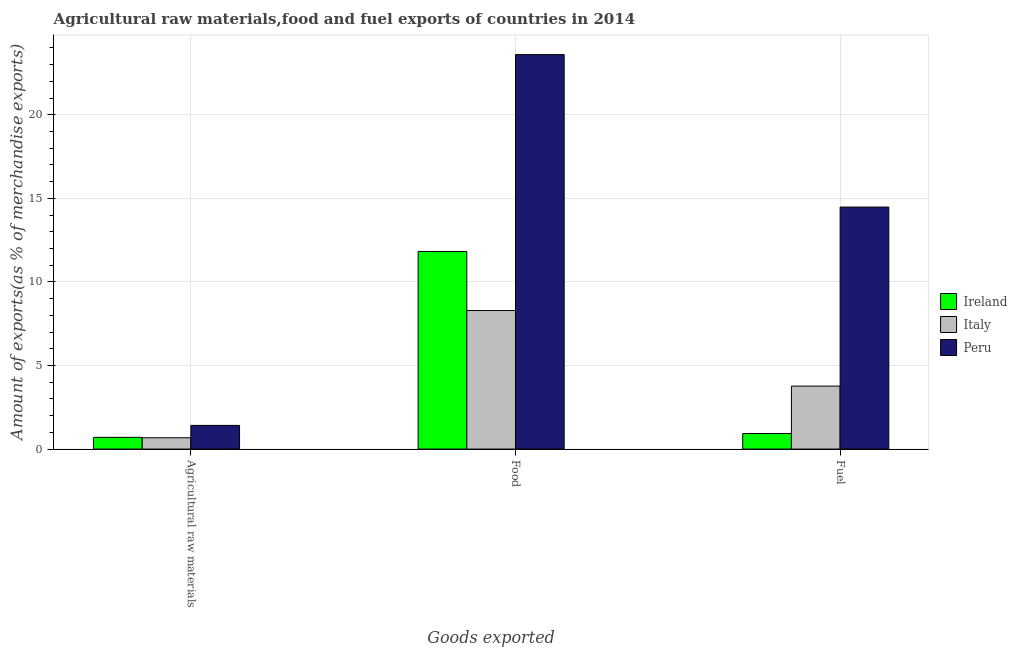Are the number of bars per tick equal to the number of legend labels?
Ensure brevity in your answer.  Yes. How many bars are there on the 3rd tick from the right?
Offer a terse response. 3. What is the label of the 2nd group of bars from the left?
Your answer should be compact. Food. What is the percentage of fuel exports in Ireland?
Your answer should be compact. 0.93. Across all countries, what is the maximum percentage of fuel exports?
Ensure brevity in your answer.  14.48. Across all countries, what is the minimum percentage of food exports?
Provide a succinct answer. 8.29. What is the total percentage of fuel exports in the graph?
Keep it short and to the point. 19.17. What is the difference between the percentage of food exports in Ireland and that in Italy?
Provide a short and direct response. 3.53. What is the difference between the percentage of food exports in Peru and the percentage of raw materials exports in Italy?
Offer a terse response. 22.92. What is the average percentage of fuel exports per country?
Give a very brief answer. 6.39. What is the difference between the percentage of raw materials exports and percentage of fuel exports in Peru?
Offer a terse response. -13.06. In how many countries, is the percentage of fuel exports greater than 18 %?
Give a very brief answer. 0. What is the ratio of the percentage of food exports in Italy to that in Peru?
Give a very brief answer. 0.35. Is the percentage of food exports in Italy less than that in Ireland?
Make the answer very short. Yes. What is the difference between the highest and the second highest percentage of raw materials exports?
Give a very brief answer. 0.71. What is the difference between the highest and the lowest percentage of food exports?
Your response must be concise. 15.31. What does the 3rd bar from the right in Food represents?
Keep it short and to the point. Ireland. Is it the case that in every country, the sum of the percentage of raw materials exports and percentage of food exports is greater than the percentage of fuel exports?
Provide a short and direct response. Yes. Are the values on the major ticks of Y-axis written in scientific E-notation?
Provide a short and direct response. No. Does the graph contain any zero values?
Offer a terse response. No. Does the graph contain grids?
Offer a very short reply. Yes. What is the title of the graph?
Keep it short and to the point. Agricultural raw materials,food and fuel exports of countries in 2014. Does "Chile" appear as one of the legend labels in the graph?
Offer a terse response. No. What is the label or title of the X-axis?
Offer a very short reply. Goods exported. What is the label or title of the Y-axis?
Provide a succinct answer. Amount of exports(as % of merchandise exports). What is the Amount of exports(as % of merchandise exports) of Ireland in Agricultural raw materials?
Provide a succinct answer. 0.7. What is the Amount of exports(as % of merchandise exports) of Italy in Agricultural raw materials?
Make the answer very short. 0.68. What is the Amount of exports(as % of merchandise exports) in Peru in Agricultural raw materials?
Your response must be concise. 1.42. What is the Amount of exports(as % of merchandise exports) in Ireland in Food?
Provide a succinct answer. 11.82. What is the Amount of exports(as % of merchandise exports) of Italy in Food?
Keep it short and to the point. 8.29. What is the Amount of exports(as % of merchandise exports) in Peru in Food?
Offer a very short reply. 23.6. What is the Amount of exports(as % of merchandise exports) of Ireland in Fuel?
Your response must be concise. 0.93. What is the Amount of exports(as % of merchandise exports) in Italy in Fuel?
Your answer should be very brief. 3.77. What is the Amount of exports(as % of merchandise exports) of Peru in Fuel?
Offer a very short reply. 14.48. Across all Goods exported, what is the maximum Amount of exports(as % of merchandise exports) of Ireland?
Your answer should be very brief. 11.82. Across all Goods exported, what is the maximum Amount of exports(as % of merchandise exports) in Italy?
Offer a terse response. 8.29. Across all Goods exported, what is the maximum Amount of exports(as % of merchandise exports) of Peru?
Ensure brevity in your answer.  23.6. Across all Goods exported, what is the minimum Amount of exports(as % of merchandise exports) of Ireland?
Your answer should be very brief. 0.7. Across all Goods exported, what is the minimum Amount of exports(as % of merchandise exports) of Italy?
Your answer should be very brief. 0.68. Across all Goods exported, what is the minimum Amount of exports(as % of merchandise exports) in Peru?
Offer a terse response. 1.42. What is the total Amount of exports(as % of merchandise exports) of Ireland in the graph?
Offer a terse response. 13.45. What is the total Amount of exports(as % of merchandise exports) in Italy in the graph?
Your answer should be compact. 12.73. What is the total Amount of exports(as % of merchandise exports) in Peru in the graph?
Provide a short and direct response. 39.49. What is the difference between the Amount of exports(as % of merchandise exports) in Ireland in Agricultural raw materials and that in Food?
Your answer should be very brief. -11.12. What is the difference between the Amount of exports(as % of merchandise exports) of Italy in Agricultural raw materials and that in Food?
Ensure brevity in your answer.  -7.61. What is the difference between the Amount of exports(as % of merchandise exports) of Peru in Agricultural raw materials and that in Food?
Your answer should be compact. -22.18. What is the difference between the Amount of exports(as % of merchandise exports) of Ireland in Agricultural raw materials and that in Fuel?
Provide a succinct answer. -0.23. What is the difference between the Amount of exports(as % of merchandise exports) in Italy in Agricultural raw materials and that in Fuel?
Offer a terse response. -3.09. What is the difference between the Amount of exports(as % of merchandise exports) in Peru in Agricultural raw materials and that in Fuel?
Provide a short and direct response. -13.06. What is the difference between the Amount of exports(as % of merchandise exports) of Ireland in Food and that in Fuel?
Provide a succinct answer. 10.89. What is the difference between the Amount of exports(as % of merchandise exports) of Italy in Food and that in Fuel?
Make the answer very short. 4.52. What is the difference between the Amount of exports(as % of merchandise exports) in Peru in Food and that in Fuel?
Your answer should be compact. 9.12. What is the difference between the Amount of exports(as % of merchandise exports) of Ireland in Agricultural raw materials and the Amount of exports(as % of merchandise exports) of Italy in Food?
Offer a terse response. -7.58. What is the difference between the Amount of exports(as % of merchandise exports) of Ireland in Agricultural raw materials and the Amount of exports(as % of merchandise exports) of Peru in Food?
Keep it short and to the point. -22.89. What is the difference between the Amount of exports(as % of merchandise exports) of Italy in Agricultural raw materials and the Amount of exports(as % of merchandise exports) of Peru in Food?
Provide a succinct answer. -22.92. What is the difference between the Amount of exports(as % of merchandise exports) of Ireland in Agricultural raw materials and the Amount of exports(as % of merchandise exports) of Italy in Fuel?
Keep it short and to the point. -3.07. What is the difference between the Amount of exports(as % of merchandise exports) of Ireland in Agricultural raw materials and the Amount of exports(as % of merchandise exports) of Peru in Fuel?
Provide a succinct answer. -13.77. What is the difference between the Amount of exports(as % of merchandise exports) of Italy in Agricultural raw materials and the Amount of exports(as % of merchandise exports) of Peru in Fuel?
Offer a very short reply. -13.8. What is the difference between the Amount of exports(as % of merchandise exports) of Ireland in Food and the Amount of exports(as % of merchandise exports) of Italy in Fuel?
Provide a succinct answer. 8.05. What is the difference between the Amount of exports(as % of merchandise exports) of Ireland in Food and the Amount of exports(as % of merchandise exports) of Peru in Fuel?
Give a very brief answer. -2.65. What is the difference between the Amount of exports(as % of merchandise exports) of Italy in Food and the Amount of exports(as % of merchandise exports) of Peru in Fuel?
Ensure brevity in your answer.  -6.19. What is the average Amount of exports(as % of merchandise exports) of Ireland per Goods exported?
Offer a terse response. 4.48. What is the average Amount of exports(as % of merchandise exports) of Italy per Goods exported?
Your answer should be compact. 4.24. What is the average Amount of exports(as % of merchandise exports) of Peru per Goods exported?
Your answer should be very brief. 13.16. What is the difference between the Amount of exports(as % of merchandise exports) in Ireland and Amount of exports(as % of merchandise exports) in Italy in Agricultural raw materials?
Your answer should be very brief. 0.02. What is the difference between the Amount of exports(as % of merchandise exports) in Ireland and Amount of exports(as % of merchandise exports) in Peru in Agricultural raw materials?
Keep it short and to the point. -0.71. What is the difference between the Amount of exports(as % of merchandise exports) in Italy and Amount of exports(as % of merchandise exports) in Peru in Agricultural raw materials?
Your response must be concise. -0.74. What is the difference between the Amount of exports(as % of merchandise exports) of Ireland and Amount of exports(as % of merchandise exports) of Italy in Food?
Make the answer very short. 3.53. What is the difference between the Amount of exports(as % of merchandise exports) in Ireland and Amount of exports(as % of merchandise exports) in Peru in Food?
Make the answer very short. -11.78. What is the difference between the Amount of exports(as % of merchandise exports) in Italy and Amount of exports(as % of merchandise exports) in Peru in Food?
Offer a very short reply. -15.31. What is the difference between the Amount of exports(as % of merchandise exports) in Ireland and Amount of exports(as % of merchandise exports) in Italy in Fuel?
Offer a terse response. -2.84. What is the difference between the Amount of exports(as % of merchandise exports) of Ireland and Amount of exports(as % of merchandise exports) of Peru in Fuel?
Provide a short and direct response. -13.55. What is the difference between the Amount of exports(as % of merchandise exports) in Italy and Amount of exports(as % of merchandise exports) in Peru in Fuel?
Your answer should be compact. -10.71. What is the ratio of the Amount of exports(as % of merchandise exports) of Ireland in Agricultural raw materials to that in Food?
Your response must be concise. 0.06. What is the ratio of the Amount of exports(as % of merchandise exports) in Italy in Agricultural raw materials to that in Food?
Make the answer very short. 0.08. What is the ratio of the Amount of exports(as % of merchandise exports) of Peru in Agricultural raw materials to that in Food?
Provide a succinct answer. 0.06. What is the ratio of the Amount of exports(as % of merchandise exports) of Ireland in Agricultural raw materials to that in Fuel?
Offer a very short reply. 0.76. What is the ratio of the Amount of exports(as % of merchandise exports) in Italy in Agricultural raw materials to that in Fuel?
Offer a terse response. 0.18. What is the ratio of the Amount of exports(as % of merchandise exports) in Peru in Agricultural raw materials to that in Fuel?
Your answer should be compact. 0.1. What is the ratio of the Amount of exports(as % of merchandise exports) of Ireland in Food to that in Fuel?
Provide a succinct answer. 12.72. What is the ratio of the Amount of exports(as % of merchandise exports) of Italy in Food to that in Fuel?
Your response must be concise. 2.2. What is the ratio of the Amount of exports(as % of merchandise exports) of Peru in Food to that in Fuel?
Provide a succinct answer. 1.63. What is the difference between the highest and the second highest Amount of exports(as % of merchandise exports) of Ireland?
Make the answer very short. 10.89. What is the difference between the highest and the second highest Amount of exports(as % of merchandise exports) of Italy?
Your answer should be very brief. 4.52. What is the difference between the highest and the second highest Amount of exports(as % of merchandise exports) in Peru?
Ensure brevity in your answer.  9.12. What is the difference between the highest and the lowest Amount of exports(as % of merchandise exports) in Ireland?
Make the answer very short. 11.12. What is the difference between the highest and the lowest Amount of exports(as % of merchandise exports) in Italy?
Give a very brief answer. 7.61. What is the difference between the highest and the lowest Amount of exports(as % of merchandise exports) of Peru?
Make the answer very short. 22.18. 